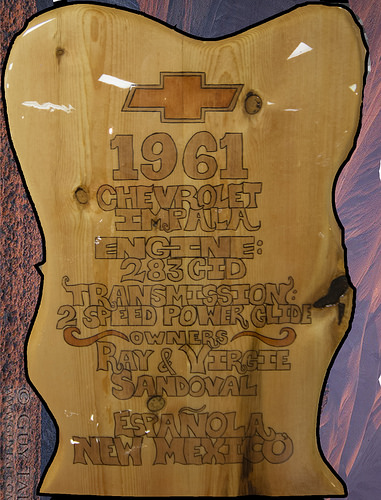<image>
Can you confirm if the symbol is on the wood? Yes. Looking at the image, I can see the symbol is positioned on top of the wood, with the wood providing support. 